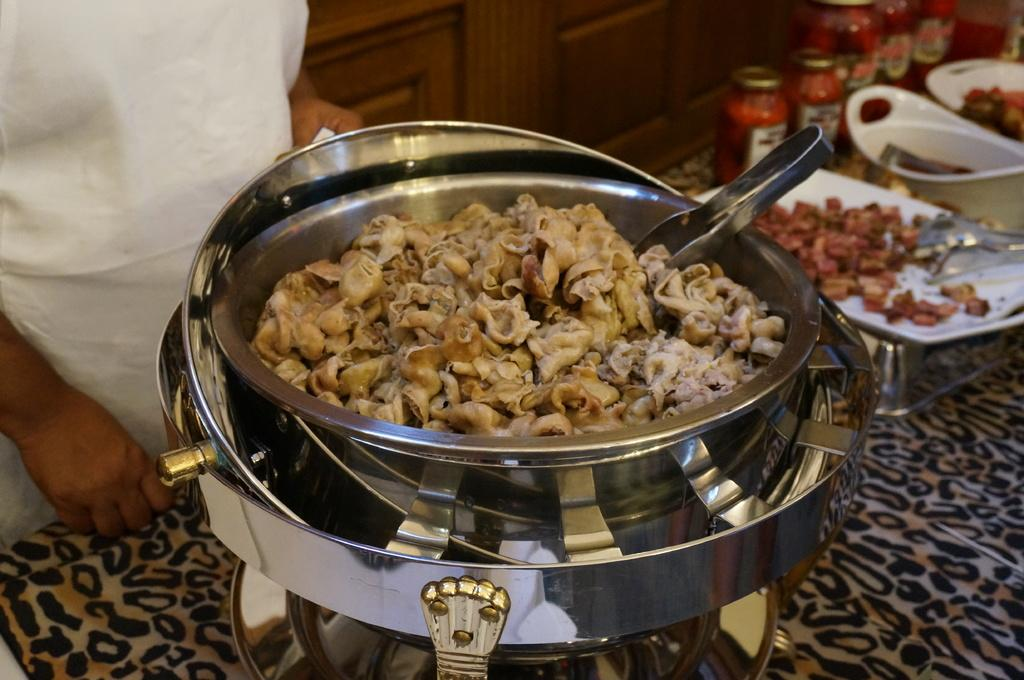What is the primary subject in the image? There is a person standing in the image. Where is the person standing? The person is standing on the floor. What type of containers can be seen in the image? There are pet jars in the image. What else is present in the image besides the person and pet jars? There are serving plates with food and tongs in the image. What type of veil is the person wearing in the image? There is no veil present in the image; the person is not wearing any head covering. 